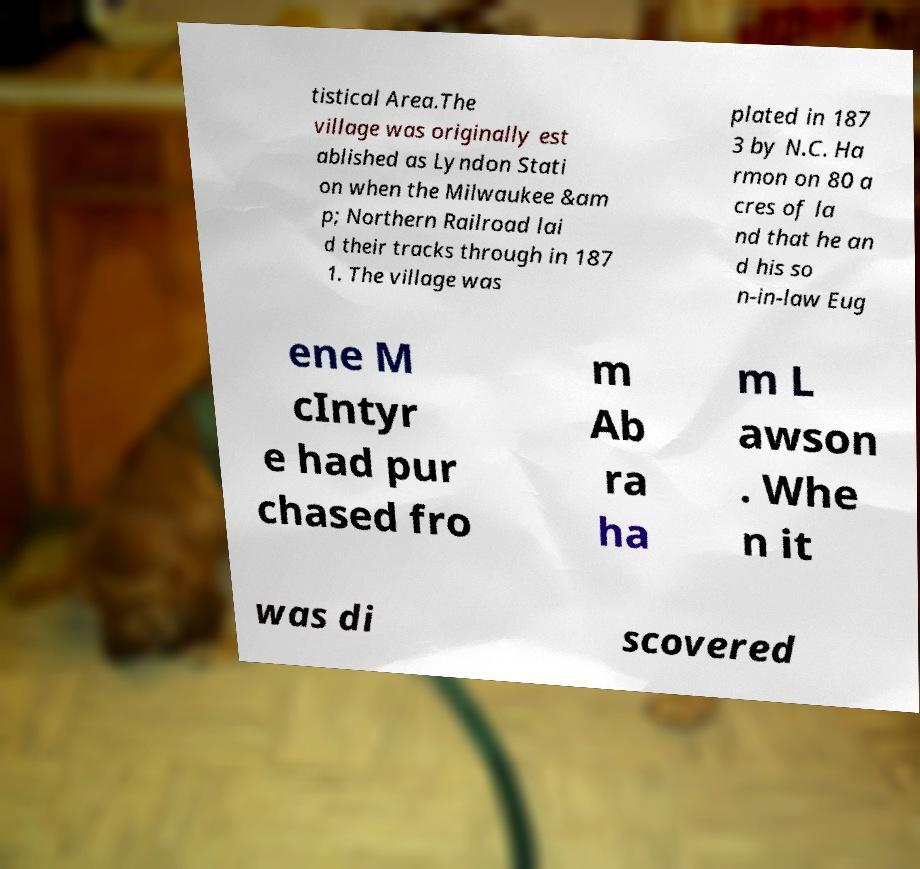Please read and relay the text visible in this image. What does it say? tistical Area.The village was originally est ablished as Lyndon Stati on when the Milwaukee &am p; Northern Railroad lai d their tracks through in 187 1. The village was plated in 187 3 by N.C. Ha rmon on 80 a cres of la nd that he an d his so n-in-law Eug ene M cIntyr e had pur chased fro m Ab ra ha m L awson . Whe n it was di scovered 